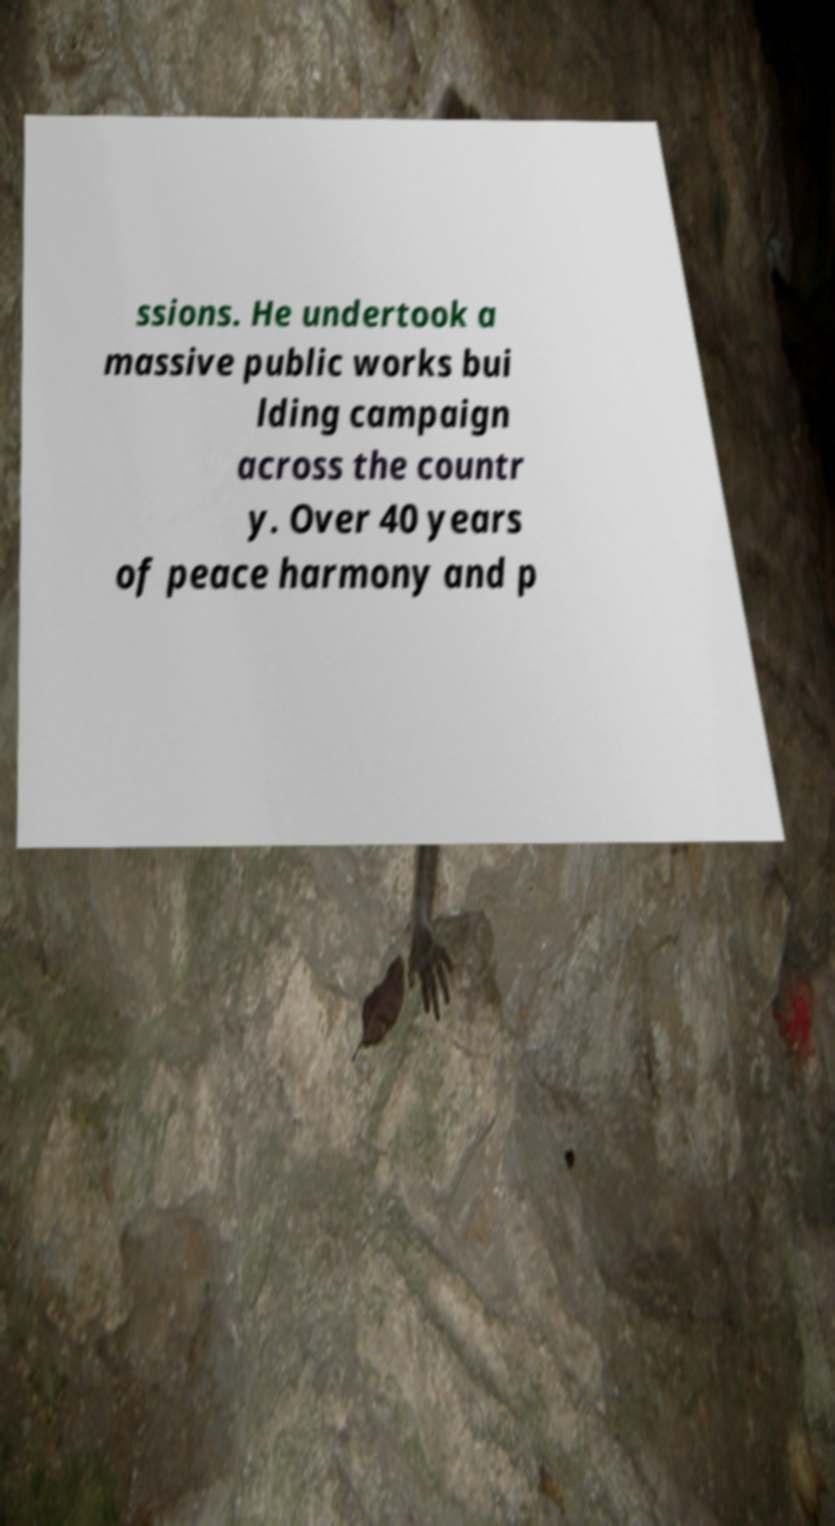There's text embedded in this image that I need extracted. Can you transcribe it verbatim? ssions. He undertook a massive public works bui lding campaign across the countr y. Over 40 years of peace harmony and p 